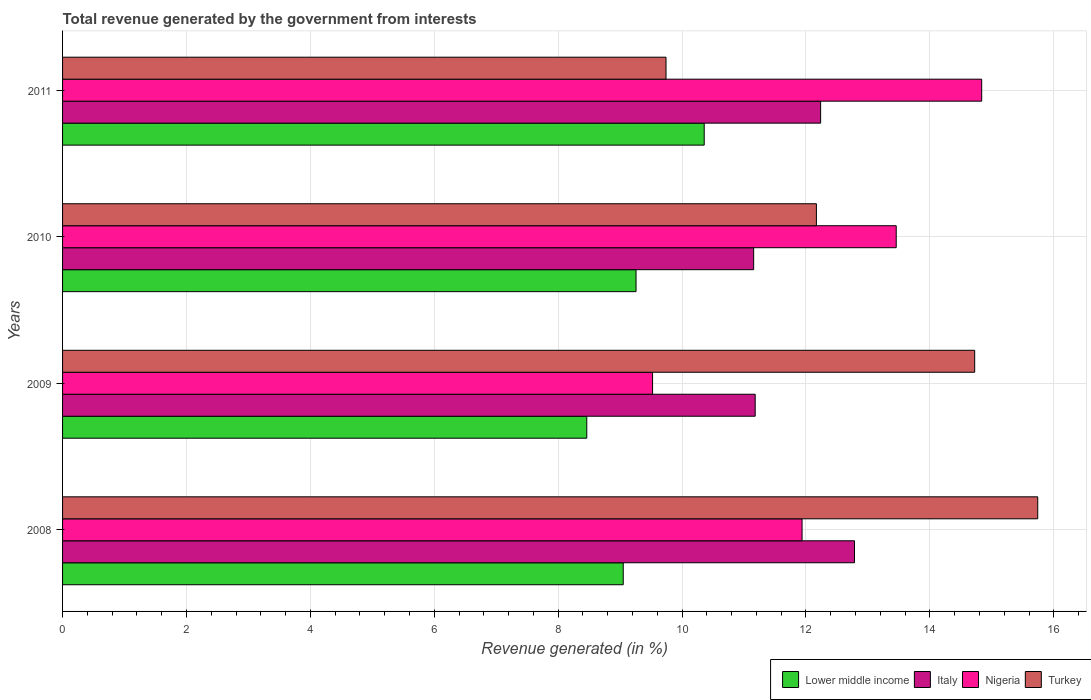How many different coloured bars are there?
Provide a short and direct response. 4. How many groups of bars are there?
Offer a very short reply. 4. Are the number of bars on each tick of the Y-axis equal?
Give a very brief answer. Yes. How many bars are there on the 2nd tick from the top?
Give a very brief answer. 4. How many bars are there on the 4th tick from the bottom?
Ensure brevity in your answer.  4. What is the total revenue generated in Lower middle income in 2009?
Offer a terse response. 8.46. Across all years, what is the maximum total revenue generated in Nigeria?
Offer a very short reply. 14.84. Across all years, what is the minimum total revenue generated in Italy?
Provide a short and direct response. 11.16. What is the total total revenue generated in Lower middle income in the graph?
Offer a terse response. 37.13. What is the difference between the total revenue generated in Turkey in 2010 and that in 2011?
Ensure brevity in your answer.  2.43. What is the difference between the total revenue generated in Nigeria in 2010 and the total revenue generated in Lower middle income in 2011?
Your answer should be very brief. 3.1. What is the average total revenue generated in Lower middle income per year?
Your answer should be compact. 9.28. In the year 2008, what is the difference between the total revenue generated in Turkey and total revenue generated in Italy?
Offer a terse response. 2.96. What is the ratio of the total revenue generated in Italy in 2008 to that in 2010?
Your response must be concise. 1.15. Is the total revenue generated in Turkey in 2009 less than that in 2011?
Make the answer very short. No. Is the difference between the total revenue generated in Turkey in 2009 and 2010 greater than the difference between the total revenue generated in Italy in 2009 and 2010?
Ensure brevity in your answer.  Yes. What is the difference between the highest and the second highest total revenue generated in Nigeria?
Your response must be concise. 1.38. What is the difference between the highest and the lowest total revenue generated in Nigeria?
Ensure brevity in your answer.  5.31. In how many years, is the total revenue generated in Italy greater than the average total revenue generated in Italy taken over all years?
Offer a very short reply. 2. Is the sum of the total revenue generated in Turkey in 2008 and 2010 greater than the maximum total revenue generated in Nigeria across all years?
Your answer should be compact. Yes. Is it the case that in every year, the sum of the total revenue generated in Italy and total revenue generated in Nigeria is greater than the sum of total revenue generated in Lower middle income and total revenue generated in Turkey?
Ensure brevity in your answer.  No. What does the 4th bar from the top in 2010 represents?
Your answer should be compact. Lower middle income. What does the 4th bar from the bottom in 2008 represents?
Your response must be concise. Turkey. How many bars are there?
Keep it short and to the point. 16. How many years are there in the graph?
Offer a terse response. 4. How are the legend labels stacked?
Your response must be concise. Horizontal. What is the title of the graph?
Your answer should be compact. Total revenue generated by the government from interests. Does "Portugal" appear as one of the legend labels in the graph?
Make the answer very short. No. What is the label or title of the X-axis?
Provide a succinct answer. Revenue generated (in %). What is the Revenue generated (in %) of Lower middle income in 2008?
Make the answer very short. 9.05. What is the Revenue generated (in %) of Italy in 2008?
Your response must be concise. 12.78. What is the Revenue generated (in %) in Nigeria in 2008?
Offer a very short reply. 11.94. What is the Revenue generated (in %) of Turkey in 2008?
Offer a very short reply. 15.74. What is the Revenue generated (in %) in Lower middle income in 2009?
Your answer should be compact. 8.46. What is the Revenue generated (in %) in Italy in 2009?
Your answer should be very brief. 11.18. What is the Revenue generated (in %) in Nigeria in 2009?
Make the answer very short. 9.52. What is the Revenue generated (in %) in Turkey in 2009?
Offer a terse response. 14.72. What is the Revenue generated (in %) of Lower middle income in 2010?
Provide a short and direct response. 9.26. What is the Revenue generated (in %) of Italy in 2010?
Keep it short and to the point. 11.16. What is the Revenue generated (in %) of Nigeria in 2010?
Your response must be concise. 13.46. What is the Revenue generated (in %) in Turkey in 2010?
Ensure brevity in your answer.  12.17. What is the Revenue generated (in %) of Lower middle income in 2011?
Keep it short and to the point. 10.36. What is the Revenue generated (in %) in Italy in 2011?
Offer a very short reply. 12.24. What is the Revenue generated (in %) of Nigeria in 2011?
Make the answer very short. 14.84. What is the Revenue generated (in %) of Turkey in 2011?
Give a very brief answer. 9.74. Across all years, what is the maximum Revenue generated (in %) of Lower middle income?
Keep it short and to the point. 10.36. Across all years, what is the maximum Revenue generated (in %) in Italy?
Offer a very short reply. 12.78. Across all years, what is the maximum Revenue generated (in %) of Nigeria?
Provide a succinct answer. 14.84. Across all years, what is the maximum Revenue generated (in %) of Turkey?
Make the answer very short. 15.74. Across all years, what is the minimum Revenue generated (in %) of Lower middle income?
Your answer should be very brief. 8.46. Across all years, what is the minimum Revenue generated (in %) in Italy?
Make the answer very short. 11.16. Across all years, what is the minimum Revenue generated (in %) in Nigeria?
Make the answer very short. 9.52. Across all years, what is the minimum Revenue generated (in %) of Turkey?
Your answer should be compact. 9.74. What is the total Revenue generated (in %) of Lower middle income in the graph?
Your answer should be very brief. 37.13. What is the total Revenue generated (in %) of Italy in the graph?
Your response must be concise. 47.35. What is the total Revenue generated (in %) in Nigeria in the graph?
Offer a very short reply. 49.75. What is the total Revenue generated (in %) in Turkey in the graph?
Make the answer very short. 52.37. What is the difference between the Revenue generated (in %) in Lower middle income in 2008 and that in 2009?
Give a very brief answer. 0.59. What is the difference between the Revenue generated (in %) of Italy in 2008 and that in 2009?
Keep it short and to the point. 1.6. What is the difference between the Revenue generated (in %) of Nigeria in 2008 and that in 2009?
Give a very brief answer. 2.41. What is the difference between the Revenue generated (in %) in Turkey in 2008 and that in 2009?
Make the answer very short. 1.02. What is the difference between the Revenue generated (in %) of Lower middle income in 2008 and that in 2010?
Give a very brief answer. -0.21. What is the difference between the Revenue generated (in %) of Italy in 2008 and that in 2010?
Keep it short and to the point. 1.63. What is the difference between the Revenue generated (in %) in Nigeria in 2008 and that in 2010?
Provide a short and direct response. -1.52. What is the difference between the Revenue generated (in %) in Turkey in 2008 and that in 2010?
Keep it short and to the point. 3.57. What is the difference between the Revenue generated (in %) in Lower middle income in 2008 and that in 2011?
Provide a short and direct response. -1.31. What is the difference between the Revenue generated (in %) of Italy in 2008 and that in 2011?
Keep it short and to the point. 0.55. What is the difference between the Revenue generated (in %) in Nigeria in 2008 and that in 2011?
Give a very brief answer. -2.9. What is the difference between the Revenue generated (in %) in Turkey in 2008 and that in 2011?
Keep it short and to the point. 6. What is the difference between the Revenue generated (in %) in Lower middle income in 2009 and that in 2010?
Keep it short and to the point. -0.79. What is the difference between the Revenue generated (in %) of Italy in 2009 and that in 2010?
Provide a short and direct response. 0.02. What is the difference between the Revenue generated (in %) of Nigeria in 2009 and that in 2010?
Offer a very short reply. -3.93. What is the difference between the Revenue generated (in %) in Turkey in 2009 and that in 2010?
Provide a short and direct response. 2.56. What is the difference between the Revenue generated (in %) in Lower middle income in 2009 and that in 2011?
Provide a succinct answer. -1.9. What is the difference between the Revenue generated (in %) of Italy in 2009 and that in 2011?
Your response must be concise. -1.06. What is the difference between the Revenue generated (in %) of Nigeria in 2009 and that in 2011?
Offer a terse response. -5.31. What is the difference between the Revenue generated (in %) in Turkey in 2009 and that in 2011?
Your answer should be very brief. 4.98. What is the difference between the Revenue generated (in %) in Lower middle income in 2010 and that in 2011?
Your answer should be very brief. -1.1. What is the difference between the Revenue generated (in %) of Italy in 2010 and that in 2011?
Provide a succinct answer. -1.08. What is the difference between the Revenue generated (in %) in Nigeria in 2010 and that in 2011?
Give a very brief answer. -1.38. What is the difference between the Revenue generated (in %) of Turkey in 2010 and that in 2011?
Ensure brevity in your answer.  2.43. What is the difference between the Revenue generated (in %) in Lower middle income in 2008 and the Revenue generated (in %) in Italy in 2009?
Provide a short and direct response. -2.13. What is the difference between the Revenue generated (in %) of Lower middle income in 2008 and the Revenue generated (in %) of Nigeria in 2009?
Offer a very short reply. -0.47. What is the difference between the Revenue generated (in %) of Lower middle income in 2008 and the Revenue generated (in %) of Turkey in 2009?
Keep it short and to the point. -5.67. What is the difference between the Revenue generated (in %) of Italy in 2008 and the Revenue generated (in %) of Nigeria in 2009?
Give a very brief answer. 3.26. What is the difference between the Revenue generated (in %) of Italy in 2008 and the Revenue generated (in %) of Turkey in 2009?
Offer a terse response. -1.94. What is the difference between the Revenue generated (in %) in Nigeria in 2008 and the Revenue generated (in %) in Turkey in 2009?
Provide a succinct answer. -2.79. What is the difference between the Revenue generated (in %) of Lower middle income in 2008 and the Revenue generated (in %) of Italy in 2010?
Provide a short and direct response. -2.11. What is the difference between the Revenue generated (in %) of Lower middle income in 2008 and the Revenue generated (in %) of Nigeria in 2010?
Offer a very short reply. -4.41. What is the difference between the Revenue generated (in %) of Lower middle income in 2008 and the Revenue generated (in %) of Turkey in 2010?
Offer a very short reply. -3.12. What is the difference between the Revenue generated (in %) in Italy in 2008 and the Revenue generated (in %) in Nigeria in 2010?
Make the answer very short. -0.67. What is the difference between the Revenue generated (in %) in Italy in 2008 and the Revenue generated (in %) in Turkey in 2010?
Ensure brevity in your answer.  0.61. What is the difference between the Revenue generated (in %) in Nigeria in 2008 and the Revenue generated (in %) in Turkey in 2010?
Offer a terse response. -0.23. What is the difference between the Revenue generated (in %) in Lower middle income in 2008 and the Revenue generated (in %) in Italy in 2011?
Provide a short and direct response. -3.19. What is the difference between the Revenue generated (in %) of Lower middle income in 2008 and the Revenue generated (in %) of Nigeria in 2011?
Ensure brevity in your answer.  -5.79. What is the difference between the Revenue generated (in %) of Lower middle income in 2008 and the Revenue generated (in %) of Turkey in 2011?
Keep it short and to the point. -0.69. What is the difference between the Revenue generated (in %) of Italy in 2008 and the Revenue generated (in %) of Nigeria in 2011?
Give a very brief answer. -2.05. What is the difference between the Revenue generated (in %) of Italy in 2008 and the Revenue generated (in %) of Turkey in 2011?
Offer a very short reply. 3.04. What is the difference between the Revenue generated (in %) in Nigeria in 2008 and the Revenue generated (in %) in Turkey in 2011?
Keep it short and to the point. 2.2. What is the difference between the Revenue generated (in %) in Lower middle income in 2009 and the Revenue generated (in %) in Italy in 2010?
Your answer should be compact. -2.69. What is the difference between the Revenue generated (in %) of Lower middle income in 2009 and the Revenue generated (in %) of Nigeria in 2010?
Your response must be concise. -4.99. What is the difference between the Revenue generated (in %) in Lower middle income in 2009 and the Revenue generated (in %) in Turkey in 2010?
Offer a terse response. -3.71. What is the difference between the Revenue generated (in %) of Italy in 2009 and the Revenue generated (in %) of Nigeria in 2010?
Give a very brief answer. -2.28. What is the difference between the Revenue generated (in %) of Italy in 2009 and the Revenue generated (in %) of Turkey in 2010?
Your answer should be very brief. -0.99. What is the difference between the Revenue generated (in %) in Nigeria in 2009 and the Revenue generated (in %) in Turkey in 2010?
Offer a terse response. -2.64. What is the difference between the Revenue generated (in %) in Lower middle income in 2009 and the Revenue generated (in %) in Italy in 2011?
Offer a very short reply. -3.77. What is the difference between the Revenue generated (in %) in Lower middle income in 2009 and the Revenue generated (in %) in Nigeria in 2011?
Your answer should be very brief. -6.37. What is the difference between the Revenue generated (in %) in Lower middle income in 2009 and the Revenue generated (in %) in Turkey in 2011?
Make the answer very short. -1.28. What is the difference between the Revenue generated (in %) of Italy in 2009 and the Revenue generated (in %) of Nigeria in 2011?
Offer a very short reply. -3.66. What is the difference between the Revenue generated (in %) of Italy in 2009 and the Revenue generated (in %) of Turkey in 2011?
Give a very brief answer. 1.44. What is the difference between the Revenue generated (in %) in Nigeria in 2009 and the Revenue generated (in %) in Turkey in 2011?
Your answer should be very brief. -0.22. What is the difference between the Revenue generated (in %) of Lower middle income in 2010 and the Revenue generated (in %) of Italy in 2011?
Provide a succinct answer. -2.98. What is the difference between the Revenue generated (in %) in Lower middle income in 2010 and the Revenue generated (in %) in Nigeria in 2011?
Give a very brief answer. -5.58. What is the difference between the Revenue generated (in %) in Lower middle income in 2010 and the Revenue generated (in %) in Turkey in 2011?
Your answer should be compact. -0.48. What is the difference between the Revenue generated (in %) in Italy in 2010 and the Revenue generated (in %) in Nigeria in 2011?
Ensure brevity in your answer.  -3.68. What is the difference between the Revenue generated (in %) in Italy in 2010 and the Revenue generated (in %) in Turkey in 2011?
Your response must be concise. 1.41. What is the difference between the Revenue generated (in %) of Nigeria in 2010 and the Revenue generated (in %) of Turkey in 2011?
Provide a succinct answer. 3.72. What is the average Revenue generated (in %) in Lower middle income per year?
Keep it short and to the point. 9.28. What is the average Revenue generated (in %) in Italy per year?
Your answer should be compact. 11.84. What is the average Revenue generated (in %) of Nigeria per year?
Keep it short and to the point. 12.44. What is the average Revenue generated (in %) in Turkey per year?
Your answer should be very brief. 13.09. In the year 2008, what is the difference between the Revenue generated (in %) of Lower middle income and Revenue generated (in %) of Italy?
Offer a very short reply. -3.73. In the year 2008, what is the difference between the Revenue generated (in %) of Lower middle income and Revenue generated (in %) of Nigeria?
Ensure brevity in your answer.  -2.89. In the year 2008, what is the difference between the Revenue generated (in %) of Lower middle income and Revenue generated (in %) of Turkey?
Keep it short and to the point. -6.69. In the year 2008, what is the difference between the Revenue generated (in %) of Italy and Revenue generated (in %) of Nigeria?
Your answer should be very brief. 0.85. In the year 2008, what is the difference between the Revenue generated (in %) in Italy and Revenue generated (in %) in Turkey?
Keep it short and to the point. -2.96. In the year 2008, what is the difference between the Revenue generated (in %) of Nigeria and Revenue generated (in %) of Turkey?
Make the answer very short. -3.8. In the year 2009, what is the difference between the Revenue generated (in %) of Lower middle income and Revenue generated (in %) of Italy?
Give a very brief answer. -2.72. In the year 2009, what is the difference between the Revenue generated (in %) in Lower middle income and Revenue generated (in %) in Nigeria?
Provide a succinct answer. -1.06. In the year 2009, what is the difference between the Revenue generated (in %) of Lower middle income and Revenue generated (in %) of Turkey?
Your answer should be very brief. -6.26. In the year 2009, what is the difference between the Revenue generated (in %) in Italy and Revenue generated (in %) in Nigeria?
Your answer should be very brief. 1.66. In the year 2009, what is the difference between the Revenue generated (in %) of Italy and Revenue generated (in %) of Turkey?
Give a very brief answer. -3.54. In the year 2009, what is the difference between the Revenue generated (in %) in Nigeria and Revenue generated (in %) in Turkey?
Make the answer very short. -5.2. In the year 2010, what is the difference between the Revenue generated (in %) in Lower middle income and Revenue generated (in %) in Italy?
Make the answer very short. -1.9. In the year 2010, what is the difference between the Revenue generated (in %) in Lower middle income and Revenue generated (in %) in Nigeria?
Offer a terse response. -4.2. In the year 2010, what is the difference between the Revenue generated (in %) in Lower middle income and Revenue generated (in %) in Turkey?
Provide a short and direct response. -2.91. In the year 2010, what is the difference between the Revenue generated (in %) of Italy and Revenue generated (in %) of Nigeria?
Make the answer very short. -2.3. In the year 2010, what is the difference between the Revenue generated (in %) in Italy and Revenue generated (in %) in Turkey?
Provide a succinct answer. -1.01. In the year 2010, what is the difference between the Revenue generated (in %) of Nigeria and Revenue generated (in %) of Turkey?
Provide a succinct answer. 1.29. In the year 2011, what is the difference between the Revenue generated (in %) of Lower middle income and Revenue generated (in %) of Italy?
Offer a terse response. -1.88. In the year 2011, what is the difference between the Revenue generated (in %) of Lower middle income and Revenue generated (in %) of Nigeria?
Your response must be concise. -4.48. In the year 2011, what is the difference between the Revenue generated (in %) of Lower middle income and Revenue generated (in %) of Turkey?
Your response must be concise. 0.62. In the year 2011, what is the difference between the Revenue generated (in %) in Italy and Revenue generated (in %) in Nigeria?
Give a very brief answer. -2.6. In the year 2011, what is the difference between the Revenue generated (in %) of Italy and Revenue generated (in %) of Turkey?
Your answer should be compact. 2.5. In the year 2011, what is the difference between the Revenue generated (in %) of Nigeria and Revenue generated (in %) of Turkey?
Provide a succinct answer. 5.1. What is the ratio of the Revenue generated (in %) of Lower middle income in 2008 to that in 2009?
Keep it short and to the point. 1.07. What is the ratio of the Revenue generated (in %) of Italy in 2008 to that in 2009?
Provide a succinct answer. 1.14. What is the ratio of the Revenue generated (in %) of Nigeria in 2008 to that in 2009?
Your answer should be very brief. 1.25. What is the ratio of the Revenue generated (in %) in Turkey in 2008 to that in 2009?
Your response must be concise. 1.07. What is the ratio of the Revenue generated (in %) of Lower middle income in 2008 to that in 2010?
Your response must be concise. 0.98. What is the ratio of the Revenue generated (in %) in Italy in 2008 to that in 2010?
Your response must be concise. 1.15. What is the ratio of the Revenue generated (in %) in Nigeria in 2008 to that in 2010?
Your answer should be compact. 0.89. What is the ratio of the Revenue generated (in %) in Turkey in 2008 to that in 2010?
Your response must be concise. 1.29. What is the ratio of the Revenue generated (in %) in Lower middle income in 2008 to that in 2011?
Offer a terse response. 0.87. What is the ratio of the Revenue generated (in %) of Italy in 2008 to that in 2011?
Keep it short and to the point. 1.04. What is the ratio of the Revenue generated (in %) of Nigeria in 2008 to that in 2011?
Provide a succinct answer. 0.8. What is the ratio of the Revenue generated (in %) in Turkey in 2008 to that in 2011?
Provide a short and direct response. 1.62. What is the ratio of the Revenue generated (in %) of Lower middle income in 2009 to that in 2010?
Provide a succinct answer. 0.91. What is the ratio of the Revenue generated (in %) of Italy in 2009 to that in 2010?
Provide a short and direct response. 1. What is the ratio of the Revenue generated (in %) of Nigeria in 2009 to that in 2010?
Make the answer very short. 0.71. What is the ratio of the Revenue generated (in %) in Turkey in 2009 to that in 2010?
Your response must be concise. 1.21. What is the ratio of the Revenue generated (in %) in Lower middle income in 2009 to that in 2011?
Ensure brevity in your answer.  0.82. What is the ratio of the Revenue generated (in %) in Italy in 2009 to that in 2011?
Ensure brevity in your answer.  0.91. What is the ratio of the Revenue generated (in %) in Nigeria in 2009 to that in 2011?
Give a very brief answer. 0.64. What is the ratio of the Revenue generated (in %) of Turkey in 2009 to that in 2011?
Ensure brevity in your answer.  1.51. What is the ratio of the Revenue generated (in %) in Lower middle income in 2010 to that in 2011?
Ensure brevity in your answer.  0.89. What is the ratio of the Revenue generated (in %) in Italy in 2010 to that in 2011?
Give a very brief answer. 0.91. What is the ratio of the Revenue generated (in %) in Nigeria in 2010 to that in 2011?
Provide a succinct answer. 0.91. What is the ratio of the Revenue generated (in %) in Turkey in 2010 to that in 2011?
Provide a short and direct response. 1.25. What is the difference between the highest and the second highest Revenue generated (in %) of Lower middle income?
Make the answer very short. 1.1. What is the difference between the highest and the second highest Revenue generated (in %) in Italy?
Ensure brevity in your answer.  0.55. What is the difference between the highest and the second highest Revenue generated (in %) of Nigeria?
Make the answer very short. 1.38. What is the difference between the highest and the second highest Revenue generated (in %) of Turkey?
Provide a short and direct response. 1.02. What is the difference between the highest and the lowest Revenue generated (in %) in Lower middle income?
Provide a succinct answer. 1.9. What is the difference between the highest and the lowest Revenue generated (in %) of Italy?
Your answer should be compact. 1.63. What is the difference between the highest and the lowest Revenue generated (in %) in Nigeria?
Your answer should be compact. 5.31. What is the difference between the highest and the lowest Revenue generated (in %) of Turkey?
Your response must be concise. 6. 